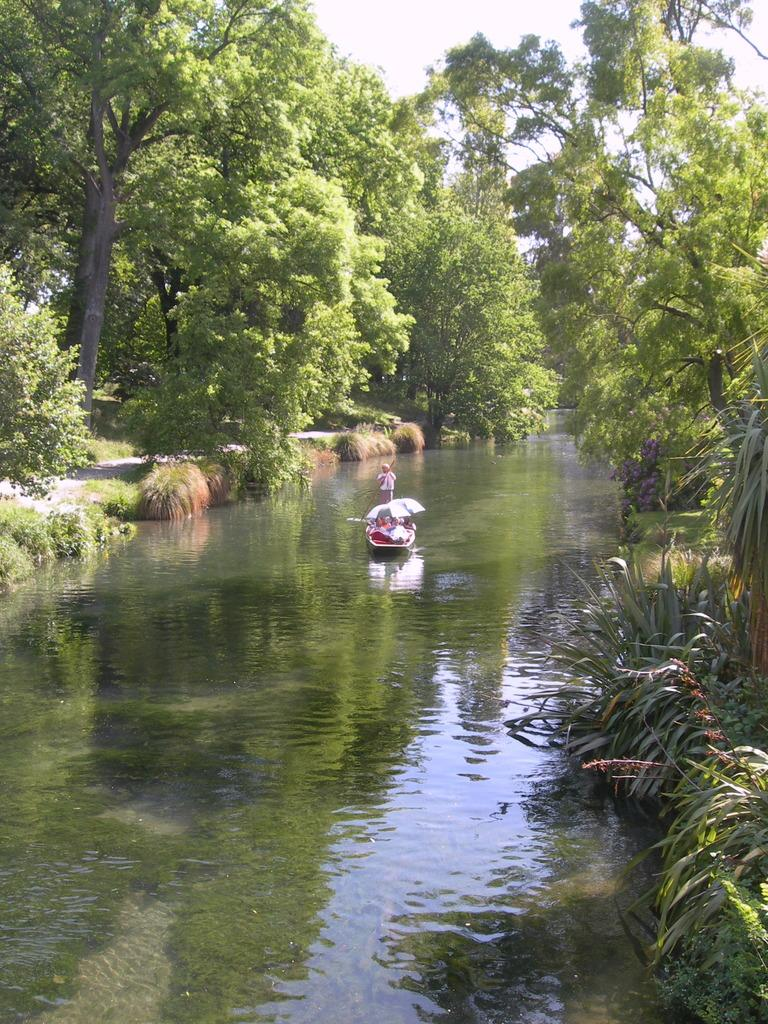What is the main subject of the image? The main subject of the image is a boat. Where is the boat located in the image? The boat is on the water. What can be seen in the background of the image? There are trees in the background of the image. What is the color of the trees? The trees are green. What is the color of the sky in the image? The sky is white in color. What grade does the picture of the boat receive for its artistic quality? The image is not an artwork, so it cannot be graded for its artistic quality. 